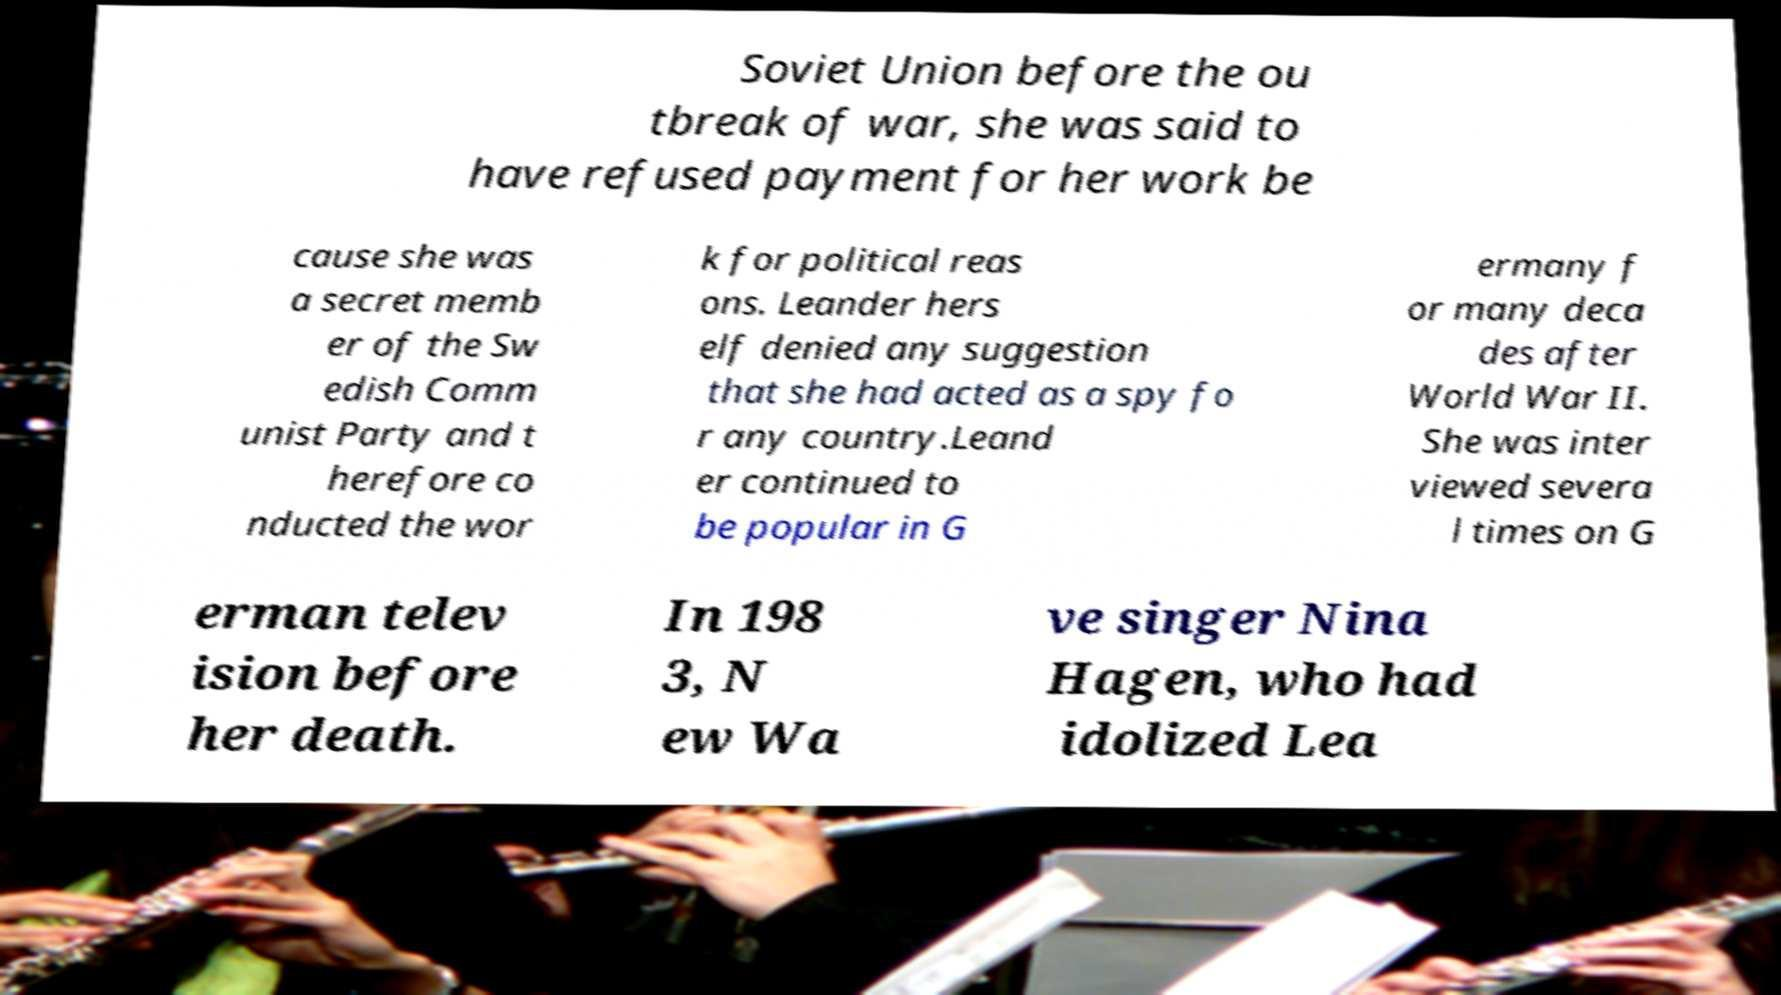Please identify and transcribe the text found in this image. Soviet Union before the ou tbreak of war, she was said to have refused payment for her work be cause she was a secret memb er of the Sw edish Comm unist Party and t herefore co nducted the wor k for political reas ons. Leander hers elf denied any suggestion that she had acted as a spy fo r any country.Leand er continued to be popular in G ermany f or many deca des after World War II. She was inter viewed severa l times on G erman telev ision before her death. In 198 3, N ew Wa ve singer Nina Hagen, who had idolized Lea 